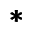<formula> <loc_0><loc_0><loc_500><loc_500>\pm b { * }</formula> 